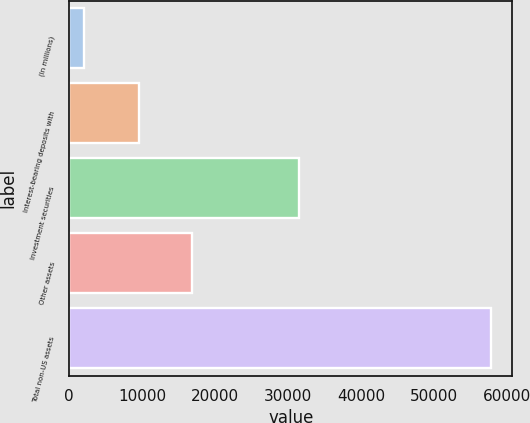Convert chart to OTSL. <chart><loc_0><loc_0><loc_500><loc_500><bar_chart><fcel>(In millions)<fcel>Interest-bearing deposits with<fcel>Investment securities<fcel>Other assets<fcel>Total non-US assets<nl><fcel>2013<fcel>9584<fcel>31522<fcel>16778<fcel>57884<nl></chart> 